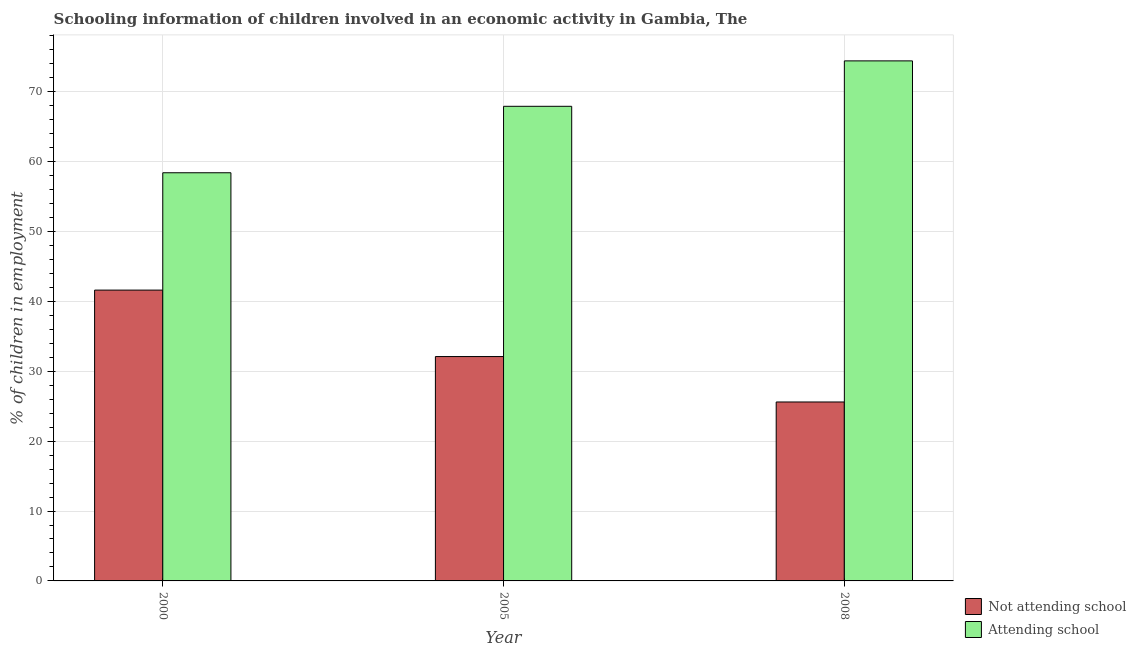How many groups of bars are there?
Provide a succinct answer. 3. Are the number of bars per tick equal to the number of legend labels?
Keep it short and to the point. Yes. How many bars are there on the 2nd tick from the right?
Keep it short and to the point. 2. What is the label of the 2nd group of bars from the left?
Your answer should be very brief. 2005. In how many cases, is the number of bars for a given year not equal to the number of legend labels?
Your response must be concise. 0. What is the percentage of employed children who are not attending school in 2008?
Offer a very short reply. 25.6. Across all years, what is the maximum percentage of employed children who are attending school?
Give a very brief answer. 74.4. Across all years, what is the minimum percentage of employed children who are not attending school?
Ensure brevity in your answer.  25.6. In which year was the percentage of employed children who are not attending school maximum?
Offer a very short reply. 2000. What is the total percentage of employed children who are not attending school in the graph?
Give a very brief answer. 99.31. What is the difference between the percentage of employed children who are attending school in 2000 and that in 2008?
Provide a succinct answer. -16.01. What is the difference between the percentage of employed children who are not attending school in 2005 and the percentage of employed children who are attending school in 2000?
Ensure brevity in your answer.  -9.51. What is the average percentage of employed children who are attending school per year?
Your response must be concise. 66.9. In how many years, is the percentage of employed children who are not attending school greater than 30 %?
Keep it short and to the point. 2. What is the ratio of the percentage of employed children who are not attending school in 2000 to that in 2005?
Your response must be concise. 1.3. Is the percentage of employed children who are attending school in 2005 less than that in 2008?
Make the answer very short. Yes. What is the difference between the highest and the lowest percentage of employed children who are attending school?
Keep it short and to the point. 16.01. In how many years, is the percentage of employed children who are attending school greater than the average percentage of employed children who are attending school taken over all years?
Your answer should be compact. 2. Is the sum of the percentage of employed children who are not attending school in 2005 and 2008 greater than the maximum percentage of employed children who are attending school across all years?
Your answer should be very brief. Yes. What does the 1st bar from the left in 2000 represents?
Provide a succinct answer. Not attending school. What does the 1st bar from the right in 2000 represents?
Provide a short and direct response. Attending school. How many bars are there?
Offer a terse response. 6. Are all the bars in the graph horizontal?
Your response must be concise. No. How many years are there in the graph?
Give a very brief answer. 3. What is the difference between two consecutive major ticks on the Y-axis?
Ensure brevity in your answer.  10. Where does the legend appear in the graph?
Provide a succinct answer. Bottom right. How are the legend labels stacked?
Your answer should be very brief. Vertical. What is the title of the graph?
Ensure brevity in your answer.  Schooling information of children involved in an economic activity in Gambia, The. What is the label or title of the X-axis?
Provide a succinct answer. Year. What is the label or title of the Y-axis?
Give a very brief answer. % of children in employment. What is the % of children in employment of Not attending school in 2000?
Offer a terse response. 41.61. What is the % of children in employment of Attending school in 2000?
Provide a succinct answer. 58.39. What is the % of children in employment in Not attending school in 2005?
Provide a succinct answer. 32.1. What is the % of children in employment of Attending school in 2005?
Offer a very short reply. 67.9. What is the % of children in employment of Not attending school in 2008?
Offer a terse response. 25.6. What is the % of children in employment in Attending school in 2008?
Provide a short and direct response. 74.4. Across all years, what is the maximum % of children in employment of Not attending school?
Keep it short and to the point. 41.61. Across all years, what is the maximum % of children in employment of Attending school?
Offer a very short reply. 74.4. Across all years, what is the minimum % of children in employment in Not attending school?
Provide a succinct answer. 25.6. Across all years, what is the minimum % of children in employment in Attending school?
Give a very brief answer. 58.39. What is the total % of children in employment in Not attending school in the graph?
Give a very brief answer. 99.31. What is the total % of children in employment of Attending school in the graph?
Make the answer very short. 200.69. What is the difference between the % of children in employment in Not attending school in 2000 and that in 2005?
Your response must be concise. 9.51. What is the difference between the % of children in employment of Attending school in 2000 and that in 2005?
Make the answer very short. -9.51. What is the difference between the % of children in employment in Not attending school in 2000 and that in 2008?
Keep it short and to the point. 16.01. What is the difference between the % of children in employment of Attending school in 2000 and that in 2008?
Give a very brief answer. -16.01. What is the difference between the % of children in employment of Not attending school in 2005 and that in 2008?
Offer a very short reply. 6.5. What is the difference between the % of children in employment of Not attending school in 2000 and the % of children in employment of Attending school in 2005?
Your answer should be very brief. -26.29. What is the difference between the % of children in employment in Not attending school in 2000 and the % of children in employment in Attending school in 2008?
Keep it short and to the point. -32.79. What is the difference between the % of children in employment in Not attending school in 2005 and the % of children in employment in Attending school in 2008?
Your answer should be very brief. -42.3. What is the average % of children in employment in Not attending school per year?
Ensure brevity in your answer.  33.1. What is the average % of children in employment of Attending school per year?
Ensure brevity in your answer.  66.9. In the year 2000, what is the difference between the % of children in employment in Not attending school and % of children in employment in Attending school?
Offer a very short reply. -16.79. In the year 2005, what is the difference between the % of children in employment in Not attending school and % of children in employment in Attending school?
Your answer should be compact. -35.8. In the year 2008, what is the difference between the % of children in employment in Not attending school and % of children in employment in Attending school?
Make the answer very short. -48.8. What is the ratio of the % of children in employment of Not attending school in 2000 to that in 2005?
Offer a terse response. 1.3. What is the ratio of the % of children in employment in Attending school in 2000 to that in 2005?
Provide a short and direct response. 0.86. What is the ratio of the % of children in employment in Not attending school in 2000 to that in 2008?
Your response must be concise. 1.63. What is the ratio of the % of children in employment in Attending school in 2000 to that in 2008?
Provide a succinct answer. 0.78. What is the ratio of the % of children in employment in Not attending school in 2005 to that in 2008?
Your answer should be compact. 1.25. What is the ratio of the % of children in employment of Attending school in 2005 to that in 2008?
Your answer should be very brief. 0.91. What is the difference between the highest and the second highest % of children in employment in Not attending school?
Provide a succinct answer. 9.51. What is the difference between the highest and the second highest % of children in employment of Attending school?
Offer a very short reply. 6.5. What is the difference between the highest and the lowest % of children in employment of Not attending school?
Give a very brief answer. 16.01. What is the difference between the highest and the lowest % of children in employment of Attending school?
Ensure brevity in your answer.  16.01. 